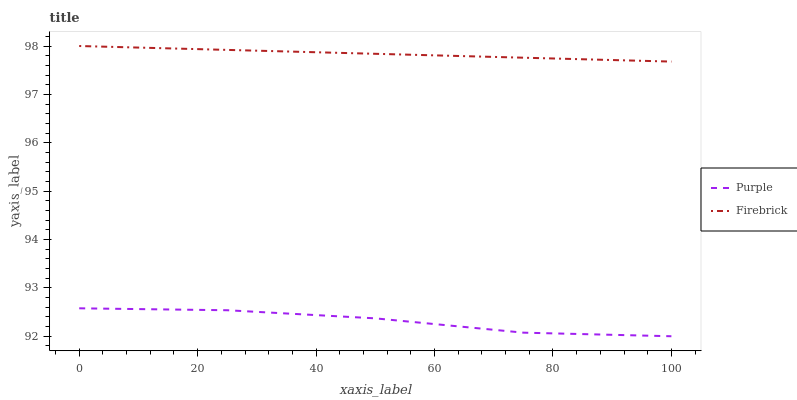Does Purple have the minimum area under the curve?
Answer yes or no. Yes. Does Firebrick have the maximum area under the curve?
Answer yes or no. Yes. Does Firebrick have the minimum area under the curve?
Answer yes or no. No. Is Firebrick the smoothest?
Answer yes or no. Yes. Is Purple the roughest?
Answer yes or no. Yes. Is Firebrick the roughest?
Answer yes or no. No. Does Firebrick have the lowest value?
Answer yes or no. No. Does Firebrick have the highest value?
Answer yes or no. Yes. Is Purple less than Firebrick?
Answer yes or no. Yes. Is Firebrick greater than Purple?
Answer yes or no. Yes. Does Purple intersect Firebrick?
Answer yes or no. No. 